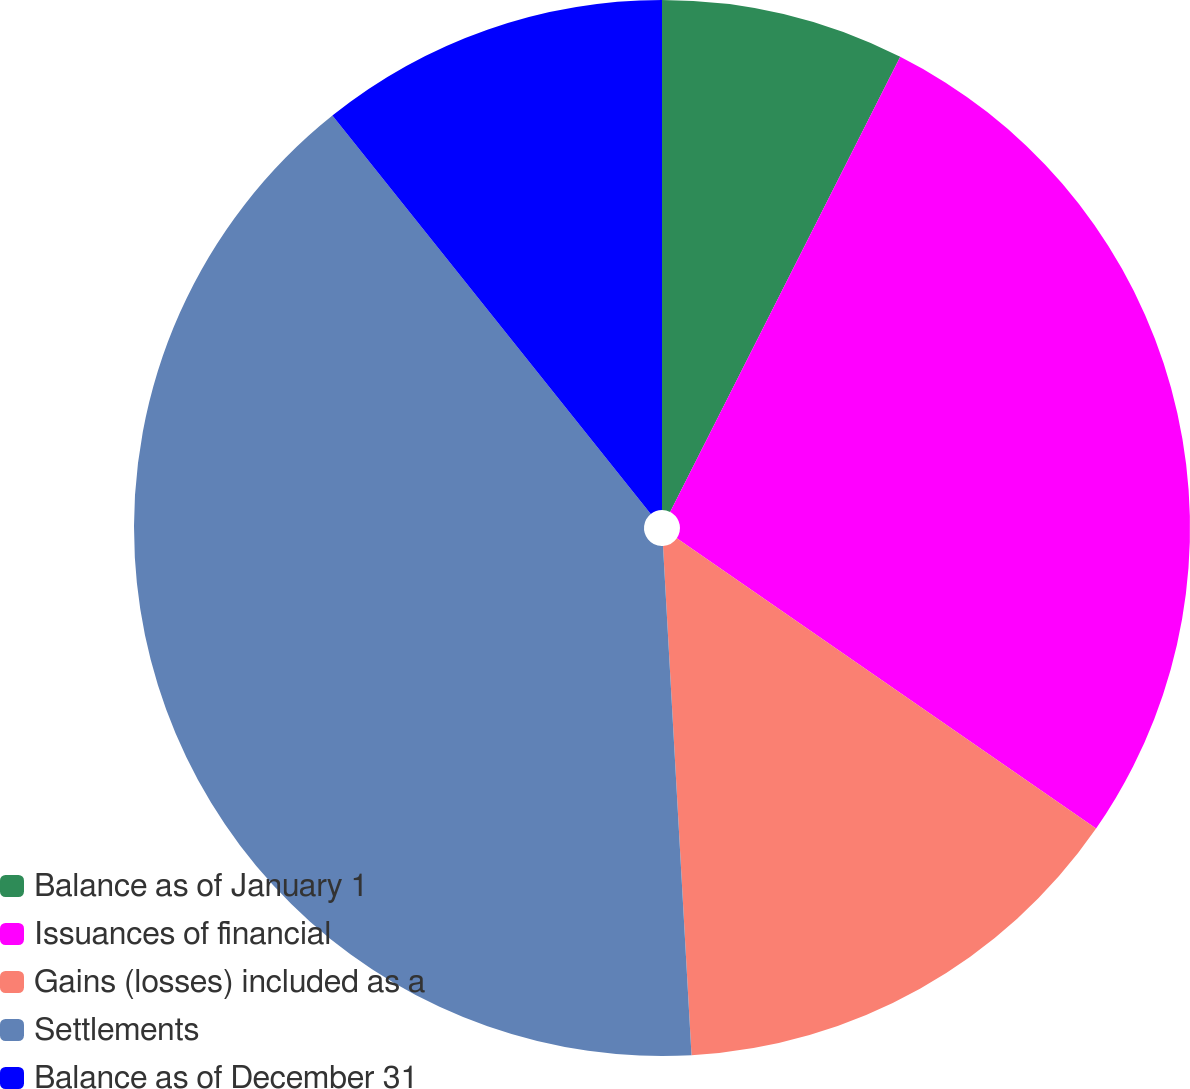Convert chart. <chart><loc_0><loc_0><loc_500><loc_500><pie_chart><fcel>Balance as of January 1<fcel>Issuances of financial<fcel>Gains (losses) included as a<fcel>Settlements<fcel>Balance as of December 31<nl><fcel>7.45%<fcel>27.19%<fcel>14.47%<fcel>40.16%<fcel>10.73%<nl></chart> 